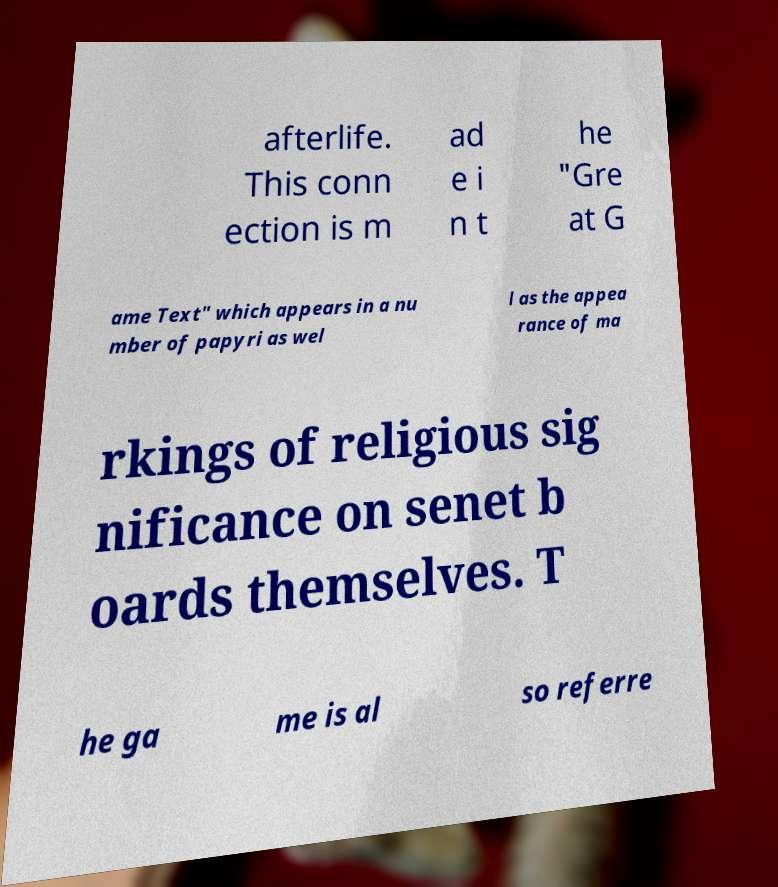Could you assist in decoding the text presented in this image and type it out clearly? afterlife. This conn ection is m ad e i n t he "Gre at G ame Text" which appears in a nu mber of papyri as wel l as the appea rance of ma rkings of religious sig nificance on senet b oards themselves. T he ga me is al so referre 